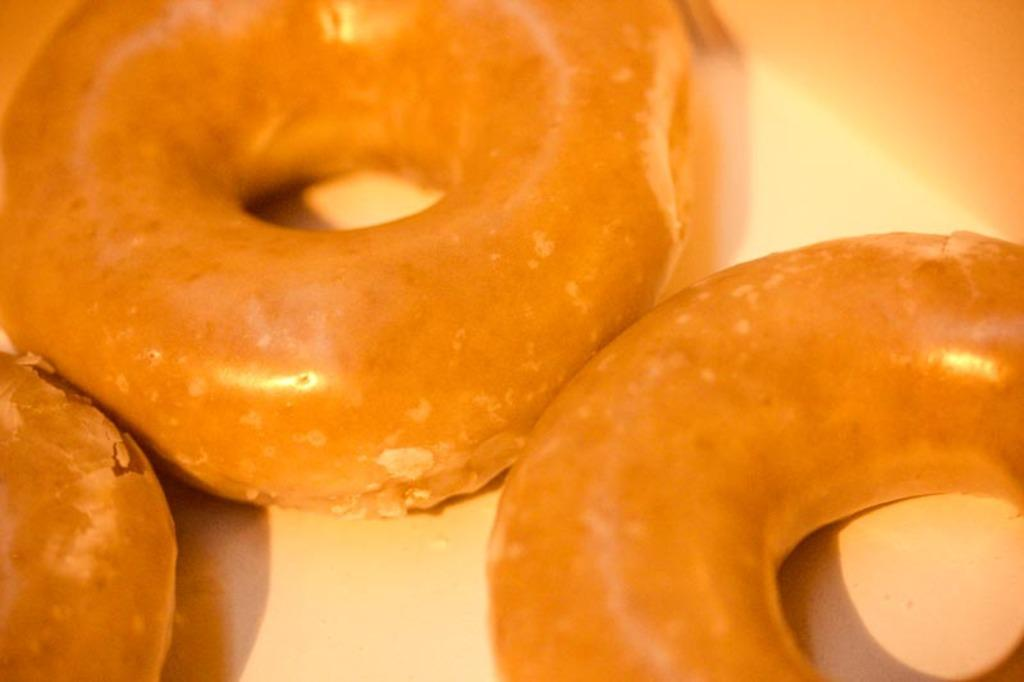What type of food can be seen in the image? There are doughnuts in the image. What is the surface on which the doughnuts are placed? The doughnuts are on a plain surface. What nation is represented by the bell in the image? There is no bell present in the image, so it is not possible to determine which nation might be represented. 